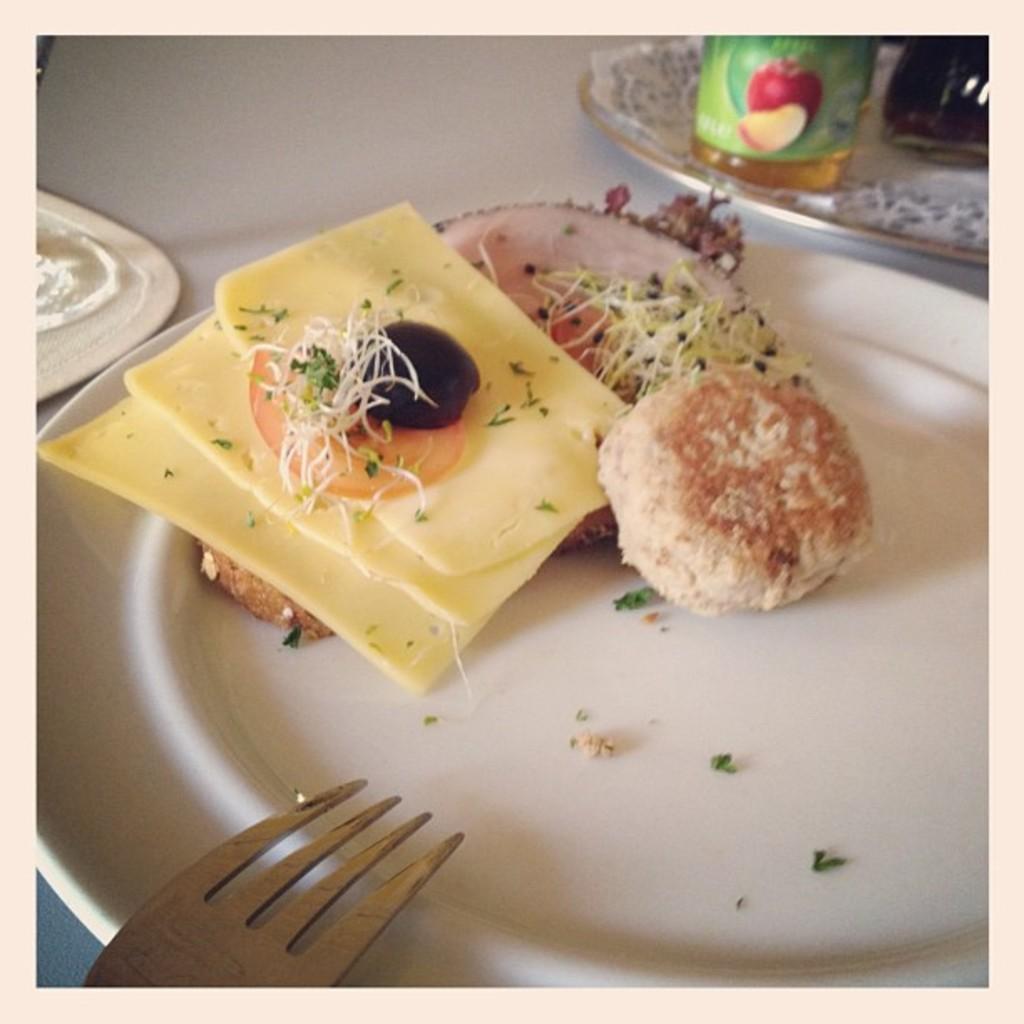Could you give a brief overview of what you see in this image? In the picture we can see a plate and on the plate there are some snacks. And there is a bottle on the table. In the left corner of the image we can see there is something. 